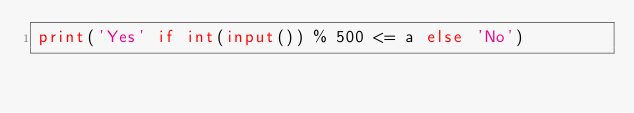<code> <loc_0><loc_0><loc_500><loc_500><_Python_>print('Yes' if int(input()) % 500 <= a else 'No')</code> 